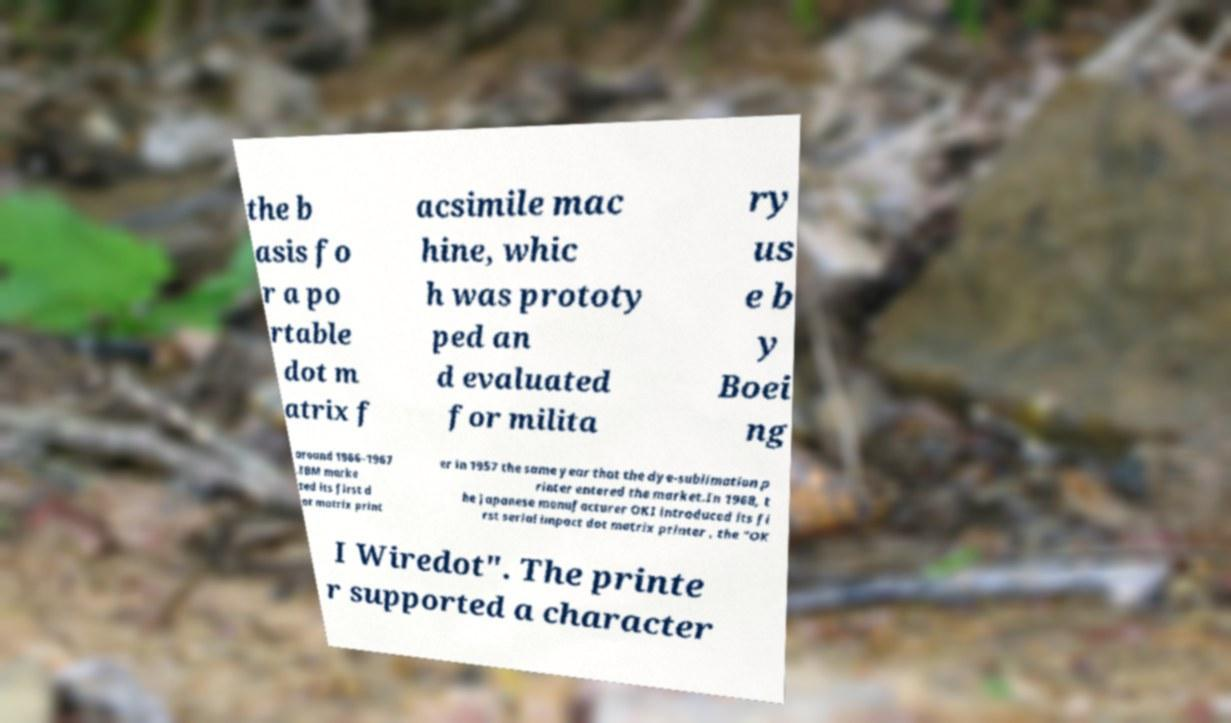There's text embedded in this image that I need extracted. Can you transcribe it verbatim? the b asis fo r a po rtable dot m atrix f acsimile mac hine, whic h was prototy ped an d evaluated for milita ry us e b y Boei ng around 1966–1967 .IBM marke ted its first d ot matrix print er in 1957 the same year that the dye-sublimation p rinter entered the market.In 1968, t he Japanese manufacturer OKI introduced its fi rst serial impact dot matrix printer , the "OK I Wiredot". The printe r supported a character 